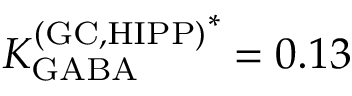<formula> <loc_0><loc_0><loc_500><loc_500>{ K _ { G A B A } ^ { ( G C , H I P P ) } } ^ { * } = 0 . 1 3</formula> 